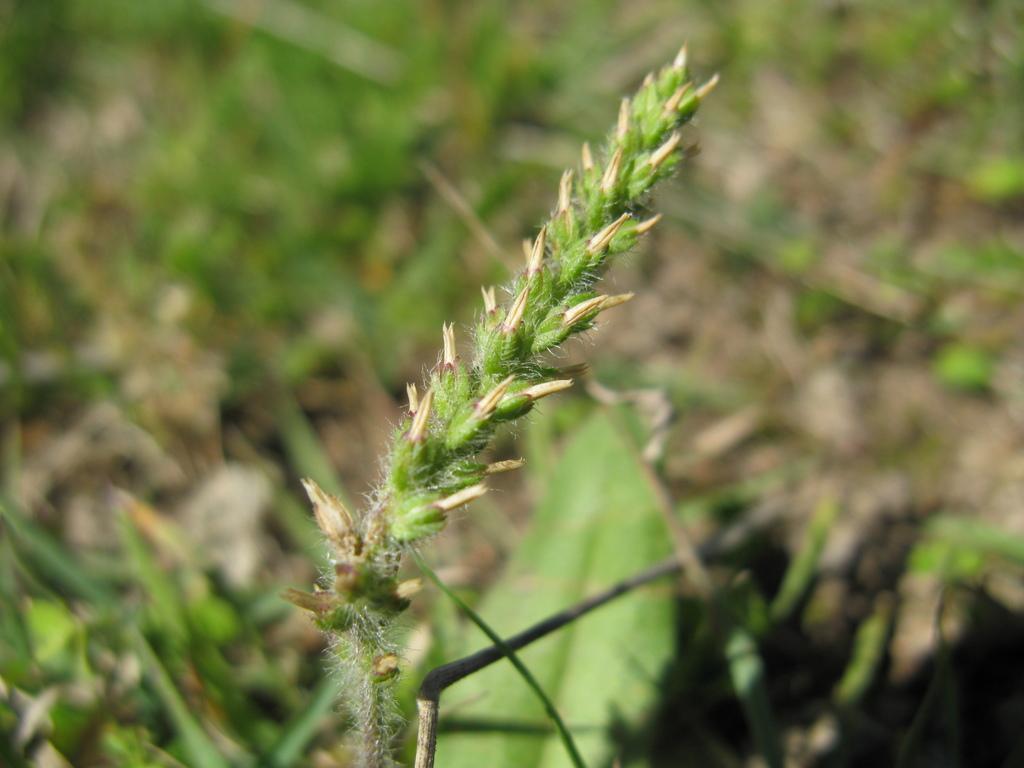Could you give a brief overview of what you see in this image? In this image I see a plant and in the background I see the green leaves and it is a bit blurred in the background. 